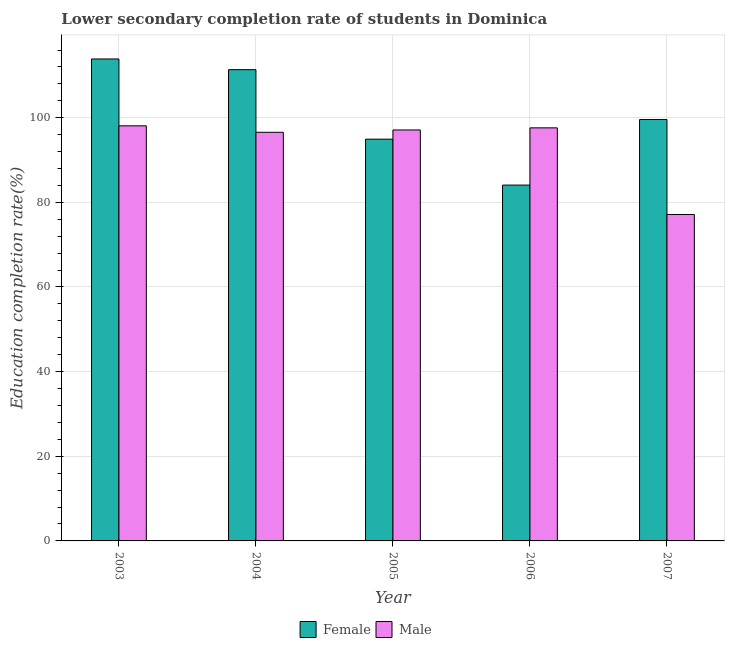How many groups of bars are there?
Your answer should be very brief. 5. How many bars are there on the 2nd tick from the left?
Provide a succinct answer. 2. What is the label of the 5th group of bars from the left?
Offer a very short reply. 2007. In how many cases, is the number of bars for a given year not equal to the number of legend labels?
Your response must be concise. 0. What is the education completion rate of female students in 2007?
Offer a terse response. 99.58. Across all years, what is the maximum education completion rate of female students?
Make the answer very short. 113.88. Across all years, what is the minimum education completion rate of male students?
Make the answer very short. 77.13. In which year was the education completion rate of male students maximum?
Offer a terse response. 2003. In which year was the education completion rate of female students minimum?
Your answer should be very brief. 2006. What is the total education completion rate of male students in the graph?
Your answer should be compact. 466.48. What is the difference between the education completion rate of male students in 2004 and that in 2007?
Your answer should be very brief. 19.42. What is the difference between the education completion rate of male students in 2004 and the education completion rate of female students in 2007?
Your answer should be compact. 19.42. What is the average education completion rate of female students per year?
Make the answer very short. 100.76. In the year 2003, what is the difference between the education completion rate of male students and education completion rate of female students?
Your answer should be very brief. 0. In how many years, is the education completion rate of male students greater than 4 %?
Your answer should be very brief. 5. What is the ratio of the education completion rate of male students in 2003 to that in 2006?
Ensure brevity in your answer.  1. What is the difference between the highest and the second highest education completion rate of male students?
Your response must be concise. 0.48. What is the difference between the highest and the lowest education completion rate of female students?
Keep it short and to the point. 29.8. What does the 1st bar from the left in 2007 represents?
Your answer should be compact. Female. How many bars are there?
Make the answer very short. 10. How many years are there in the graph?
Ensure brevity in your answer.  5. Are the values on the major ticks of Y-axis written in scientific E-notation?
Give a very brief answer. No. Does the graph contain grids?
Make the answer very short. Yes. Where does the legend appear in the graph?
Your response must be concise. Bottom center. How many legend labels are there?
Your response must be concise. 2. What is the title of the graph?
Provide a short and direct response. Lower secondary completion rate of students in Dominica. What is the label or title of the X-axis?
Ensure brevity in your answer.  Year. What is the label or title of the Y-axis?
Your answer should be compact. Education completion rate(%). What is the Education completion rate(%) of Female in 2003?
Your answer should be compact. 113.88. What is the Education completion rate(%) in Male in 2003?
Make the answer very short. 98.08. What is the Education completion rate(%) in Female in 2004?
Provide a succinct answer. 111.35. What is the Education completion rate(%) in Male in 2004?
Ensure brevity in your answer.  96.56. What is the Education completion rate(%) of Female in 2005?
Your response must be concise. 94.93. What is the Education completion rate(%) of Male in 2005?
Offer a terse response. 97.11. What is the Education completion rate(%) in Female in 2006?
Offer a very short reply. 84.08. What is the Education completion rate(%) in Male in 2006?
Your answer should be very brief. 97.6. What is the Education completion rate(%) of Female in 2007?
Keep it short and to the point. 99.58. What is the Education completion rate(%) of Male in 2007?
Your answer should be very brief. 77.13. Across all years, what is the maximum Education completion rate(%) in Female?
Offer a very short reply. 113.88. Across all years, what is the maximum Education completion rate(%) of Male?
Your answer should be very brief. 98.08. Across all years, what is the minimum Education completion rate(%) of Female?
Provide a succinct answer. 84.08. Across all years, what is the minimum Education completion rate(%) in Male?
Make the answer very short. 77.13. What is the total Education completion rate(%) of Female in the graph?
Your answer should be compact. 503.82. What is the total Education completion rate(%) in Male in the graph?
Make the answer very short. 466.48. What is the difference between the Education completion rate(%) in Female in 2003 and that in 2004?
Offer a very short reply. 2.53. What is the difference between the Education completion rate(%) of Male in 2003 and that in 2004?
Your answer should be very brief. 1.53. What is the difference between the Education completion rate(%) in Female in 2003 and that in 2005?
Make the answer very short. 18.95. What is the difference between the Education completion rate(%) of Male in 2003 and that in 2005?
Offer a very short reply. 0.98. What is the difference between the Education completion rate(%) in Female in 2003 and that in 2006?
Make the answer very short. 29.8. What is the difference between the Education completion rate(%) of Male in 2003 and that in 2006?
Ensure brevity in your answer.  0.48. What is the difference between the Education completion rate(%) of Female in 2003 and that in 2007?
Offer a very short reply. 14.3. What is the difference between the Education completion rate(%) in Male in 2003 and that in 2007?
Ensure brevity in your answer.  20.95. What is the difference between the Education completion rate(%) of Female in 2004 and that in 2005?
Give a very brief answer. 16.42. What is the difference between the Education completion rate(%) of Male in 2004 and that in 2005?
Provide a short and direct response. -0.55. What is the difference between the Education completion rate(%) in Female in 2004 and that in 2006?
Ensure brevity in your answer.  27.27. What is the difference between the Education completion rate(%) in Male in 2004 and that in 2006?
Your response must be concise. -1.05. What is the difference between the Education completion rate(%) of Female in 2004 and that in 2007?
Ensure brevity in your answer.  11.78. What is the difference between the Education completion rate(%) in Male in 2004 and that in 2007?
Provide a short and direct response. 19.42. What is the difference between the Education completion rate(%) in Female in 2005 and that in 2006?
Ensure brevity in your answer.  10.85. What is the difference between the Education completion rate(%) of Male in 2005 and that in 2006?
Your answer should be compact. -0.5. What is the difference between the Education completion rate(%) in Female in 2005 and that in 2007?
Your response must be concise. -4.64. What is the difference between the Education completion rate(%) in Male in 2005 and that in 2007?
Give a very brief answer. 19.98. What is the difference between the Education completion rate(%) of Female in 2006 and that in 2007?
Provide a succinct answer. -15.5. What is the difference between the Education completion rate(%) of Male in 2006 and that in 2007?
Your answer should be compact. 20.47. What is the difference between the Education completion rate(%) of Female in 2003 and the Education completion rate(%) of Male in 2004?
Make the answer very short. 17.32. What is the difference between the Education completion rate(%) of Female in 2003 and the Education completion rate(%) of Male in 2005?
Provide a short and direct response. 16.77. What is the difference between the Education completion rate(%) in Female in 2003 and the Education completion rate(%) in Male in 2006?
Your response must be concise. 16.28. What is the difference between the Education completion rate(%) in Female in 2003 and the Education completion rate(%) in Male in 2007?
Provide a succinct answer. 36.75. What is the difference between the Education completion rate(%) of Female in 2004 and the Education completion rate(%) of Male in 2005?
Provide a short and direct response. 14.25. What is the difference between the Education completion rate(%) in Female in 2004 and the Education completion rate(%) in Male in 2006?
Offer a terse response. 13.75. What is the difference between the Education completion rate(%) of Female in 2004 and the Education completion rate(%) of Male in 2007?
Your response must be concise. 34.22. What is the difference between the Education completion rate(%) in Female in 2005 and the Education completion rate(%) in Male in 2006?
Keep it short and to the point. -2.67. What is the difference between the Education completion rate(%) in Female in 2005 and the Education completion rate(%) in Male in 2007?
Offer a terse response. 17.8. What is the difference between the Education completion rate(%) of Female in 2006 and the Education completion rate(%) of Male in 2007?
Keep it short and to the point. 6.95. What is the average Education completion rate(%) of Female per year?
Your answer should be compact. 100.76. What is the average Education completion rate(%) in Male per year?
Keep it short and to the point. 93.3. In the year 2003, what is the difference between the Education completion rate(%) of Female and Education completion rate(%) of Male?
Ensure brevity in your answer.  15.8. In the year 2004, what is the difference between the Education completion rate(%) of Female and Education completion rate(%) of Male?
Your answer should be very brief. 14.8. In the year 2005, what is the difference between the Education completion rate(%) of Female and Education completion rate(%) of Male?
Provide a short and direct response. -2.17. In the year 2006, what is the difference between the Education completion rate(%) of Female and Education completion rate(%) of Male?
Offer a terse response. -13.52. In the year 2007, what is the difference between the Education completion rate(%) of Female and Education completion rate(%) of Male?
Your answer should be compact. 22.44. What is the ratio of the Education completion rate(%) of Female in 2003 to that in 2004?
Your answer should be very brief. 1.02. What is the ratio of the Education completion rate(%) of Male in 2003 to that in 2004?
Your response must be concise. 1.02. What is the ratio of the Education completion rate(%) of Female in 2003 to that in 2005?
Make the answer very short. 1.2. What is the ratio of the Education completion rate(%) of Male in 2003 to that in 2005?
Offer a terse response. 1.01. What is the ratio of the Education completion rate(%) of Female in 2003 to that in 2006?
Your answer should be very brief. 1.35. What is the ratio of the Education completion rate(%) of Female in 2003 to that in 2007?
Ensure brevity in your answer.  1.14. What is the ratio of the Education completion rate(%) in Male in 2003 to that in 2007?
Make the answer very short. 1.27. What is the ratio of the Education completion rate(%) of Female in 2004 to that in 2005?
Keep it short and to the point. 1.17. What is the ratio of the Education completion rate(%) of Male in 2004 to that in 2005?
Offer a terse response. 0.99. What is the ratio of the Education completion rate(%) in Female in 2004 to that in 2006?
Your answer should be compact. 1.32. What is the ratio of the Education completion rate(%) in Male in 2004 to that in 2006?
Offer a very short reply. 0.99. What is the ratio of the Education completion rate(%) of Female in 2004 to that in 2007?
Provide a succinct answer. 1.12. What is the ratio of the Education completion rate(%) of Male in 2004 to that in 2007?
Provide a short and direct response. 1.25. What is the ratio of the Education completion rate(%) in Female in 2005 to that in 2006?
Your response must be concise. 1.13. What is the ratio of the Education completion rate(%) in Male in 2005 to that in 2006?
Ensure brevity in your answer.  0.99. What is the ratio of the Education completion rate(%) of Female in 2005 to that in 2007?
Offer a terse response. 0.95. What is the ratio of the Education completion rate(%) of Male in 2005 to that in 2007?
Your response must be concise. 1.26. What is the ratio of the Education completion rate(%) in Female in 2006 to that in 2007?
Offer a very short reply. 0.84. What is the ratio of the Education completion rate(%) in Male in 2006 to that in 2007?
Make the answer very short. 1.27. What is the difference between the highest and the second highest Education completion rate(%) of Female?
Provide a succinct answer. 2.53. What is the difference between the highest and the second highest Education completion rate(%) in Male?
Provide a succinct answer. 0.48. What is the difference between the highest and the lowest Education completion rate(%) of Female?
Keep it short and to the point. 29.8. What is the difference between the highest and the lowest Education completion rate(%) in Male?
Keep it short and to the point. 20.95. 